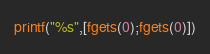Convert code to text. <code><loc_0><loc_0><loc_500><loc_500><_Octave_>printf("%s",[fgets(0);fgets(0)])</code> 